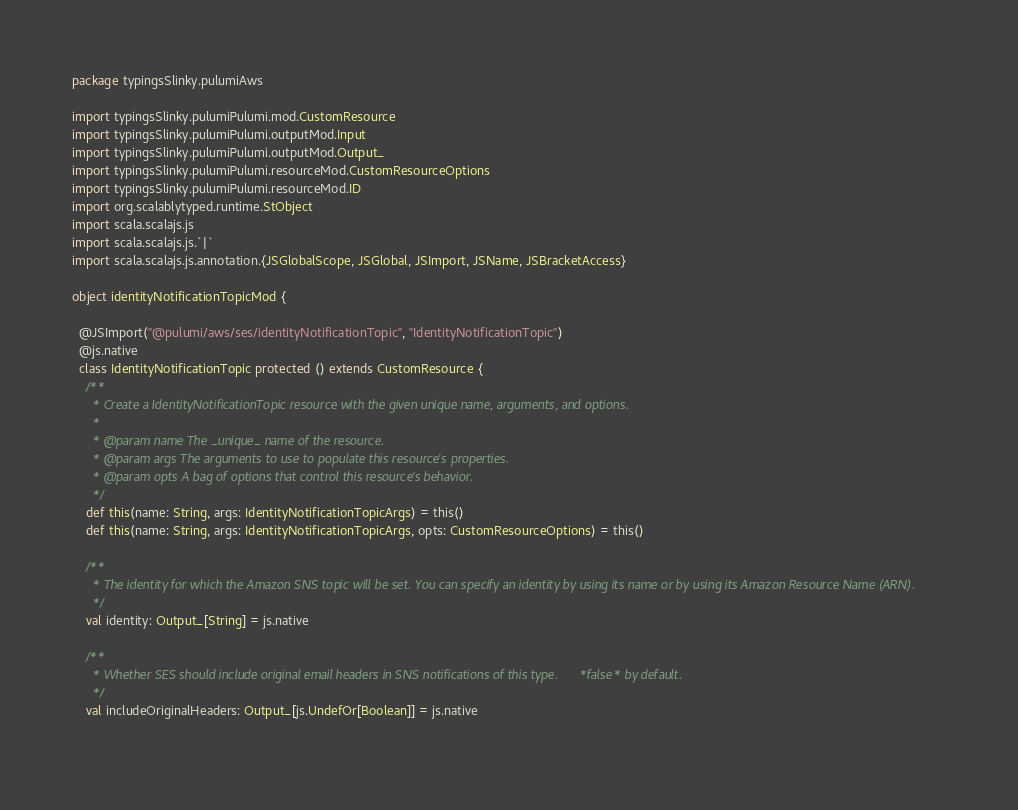<code> <loc_0><loc_0><loc_500><loc_500><_Scala_>package typingsSlinky.pulumiAws

import typingsSlinky.pulumiPulumi.mod.CustomResource
import typingsSlinky.pulumiPulumi.outputMod.Input
import typingsSlinky.pulumiPulumi.outputMod.Output_
import typingsSlinky.pulumiPulumi.resourceMod.CustomResourceOptions
import typingsSlinky.pulumiPulumi.resourceMod.ID
import org.scalablytyped.runtime.StObject
import scala.scalajs.js
import scala.scalajs.js.`|`
import scala.scalajs.js.annotation.{JSGlobalScope, JSGlobal, JSImport, JSName, JSBracketAccess}

object identityNotificationTopicMod {
  
  @JSImport("@pulumi/aws/ses/identityNotificationTopic", "IdentityNotificationTopic")
  @js.native
  class IdentityNotificationTopic protected () extends CustomResource {
    /**
      * Create a IdentityNotificationTopic resource with the given unique name, arguments, and options.
      *
      * @param name The _unique_ name of the resource.
      * @param args The arguments to use to populate this resource's properties.
      * @param opts A bag of options that control this resource's behavior.
      */
    def this(name: String, args: IdentityNotificationTopicArgs) = this()
    def this(name: String, args: IdentityNotificationTopicArgs, opts: CustomResourceOptions) = this()
    
    /**
      * The identity for which the Amazon SNS topic will be set. You can specify an identity by using its name or by using its Amazon Resource Name (ARN).
      */
    val identity: Output_[String] = js.native
    
    /**
      * Whether SES should include original email headers in SNS notifications of this type. *false* by default.
      */
    val includeOriginalHeaders: Output_[js.UndefOr[Boolean]] = js.native
    </code> 